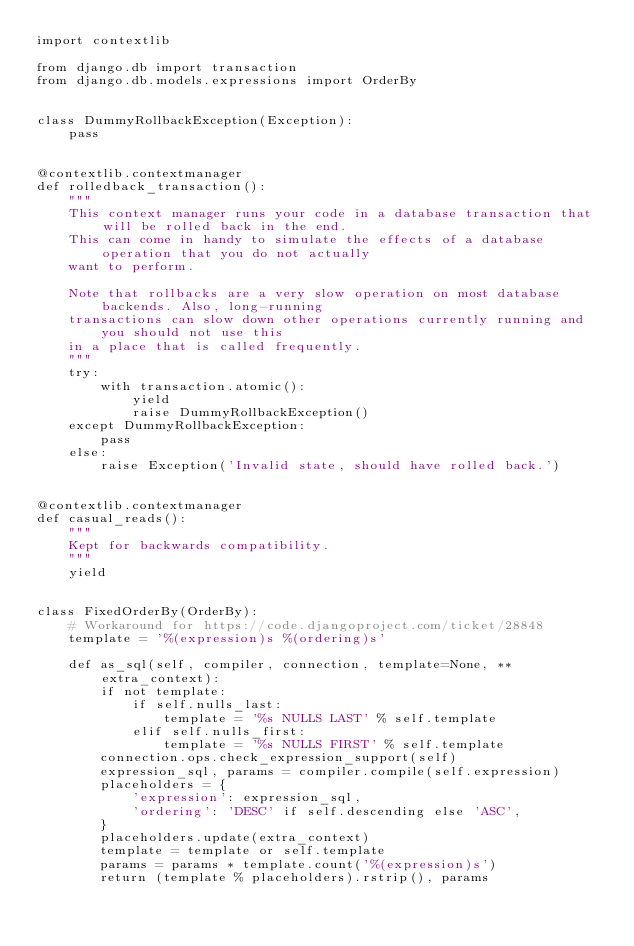<code> <loc_0><loc_0><loc_500><loc_500><_Python_>import contextlib

from django.db import transaction
from django.db.models.expressions import OrderBy


class DummyRollbackException(Exception):
    pass


@contextlib.contextmanager
def rolledback_transaction():
    """
    This context manager runs your code in a database transaction that will be rolled back in the end.
    This can come in handy to simulate the effects of a database operation that you do not actually
    want to perform.

    Note that rollbacks are a very slow operation on most database backends. Also, long-running
    transactions can slow down other operations currently running and you should not use this
    in a place that is called frequently.
    """
    try:
        with transaction.atomic():
            yield
            raise DummyRollbackException()
    except DummyRollbackException:
        pass
    else:
        raise Exception('Invalid state, should have rolled back.')


@contextlib.contextmanager
def casual_reads():
    """
    Kept for backwards compatibility.
    """
    yield


class FixedOrderBy(OrderBy):
    # Workaround for https://code.djangoproject.com/ticket/28848
    template = '%(expression)s %(ordering)s'

    def as_sql(self, compiler, connection, template=None, **extra_context):
        if not template:
            if self.nulls_last:
                template = '%s NULLS LAST' % self.template
            elif self.nulls_first:
                template = '%s NULLS FIRST' % self.template
        connection.ops.check_expression_support(self)
        expression_sql, params = compiler.compile(self.expression)
        placeholders = {
            'expression': expression_sql,
            'ordering': 'DESC' if self.descending else 'ASC',
        }
        placeholders.update(extra_context)
        template = template or self.template
        params = params * template.count('%(expression)s')
        return (template % placeholders).rstrip(), params
</code> 